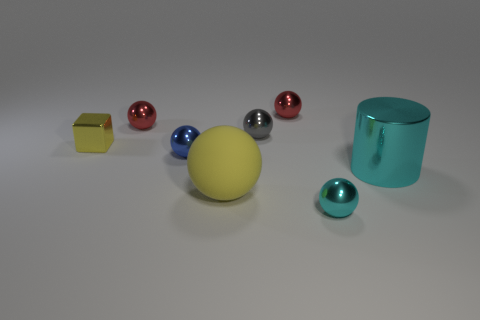Is the big shiny object the same shape as the matte thing?
Offer a very short reply. No. How many large things are either red metallic spheres or yellow rubber things?
Your response must be concise. 1. The large metallic cylinder has what color?
Offer a terse response. Cyan. The tiny red thing in front of the small red metal sphere that is to the right of the small blue object is what shape?
Ensure brevity in your answer.  Sphere. Is there a red ball made of the same material as the small yellow thing?
Provide a short and direct response. Yes. Do the red ball that is to the right of the gray ball and the large yellow rubber thing have the same size?
Make the answer very short. No. What number of blue things are either metal spheres or large cylinders?
Your response must be concise. 1. There is a tiny thing in front of the big cylinder; what is it made of?
Your response must be concise. Metal. How many metal things are right of the tiny red ball on the right side of the blue object?
Provide a short and direct response. 2. What number of other big yellow things have the same shape as the big yellow object?
Offer a very short reply. 0. 